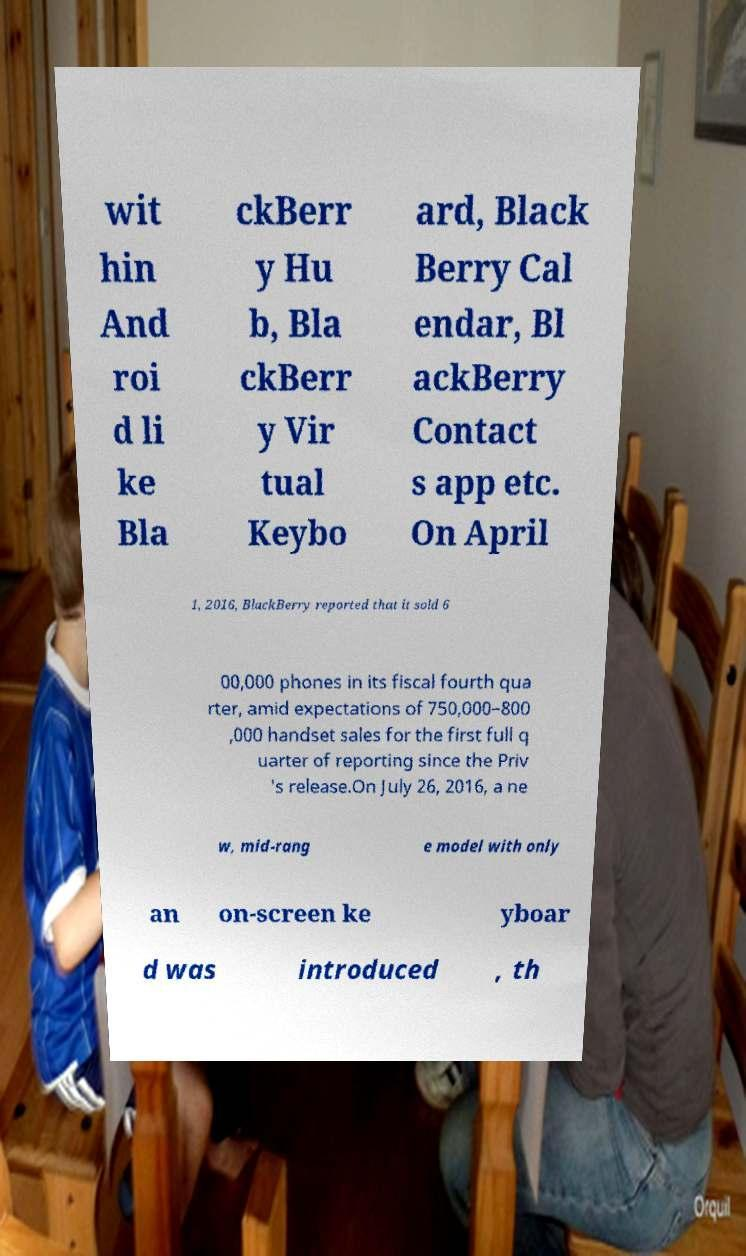Please identify and transcribe the text found in this image. wit hin And roi d li ke Bla ckBerr y Hu b, Bla ckBerr y Vir tual Keybo ard, Black Berry Cal endar, Bl ackBerry Contact s app etc. On April 1, 2016, BlackBerry reported that it sold 6 00,000 phones in its fiscal fourth qua rter, amid expectations of 750,000–800 ,000 handset sales for the first full q uarter of reporting since the Priv 's release.On July 26, 2016, a ne w, mid-rang e model with only an on-screen ke yboar d was introduced , th 